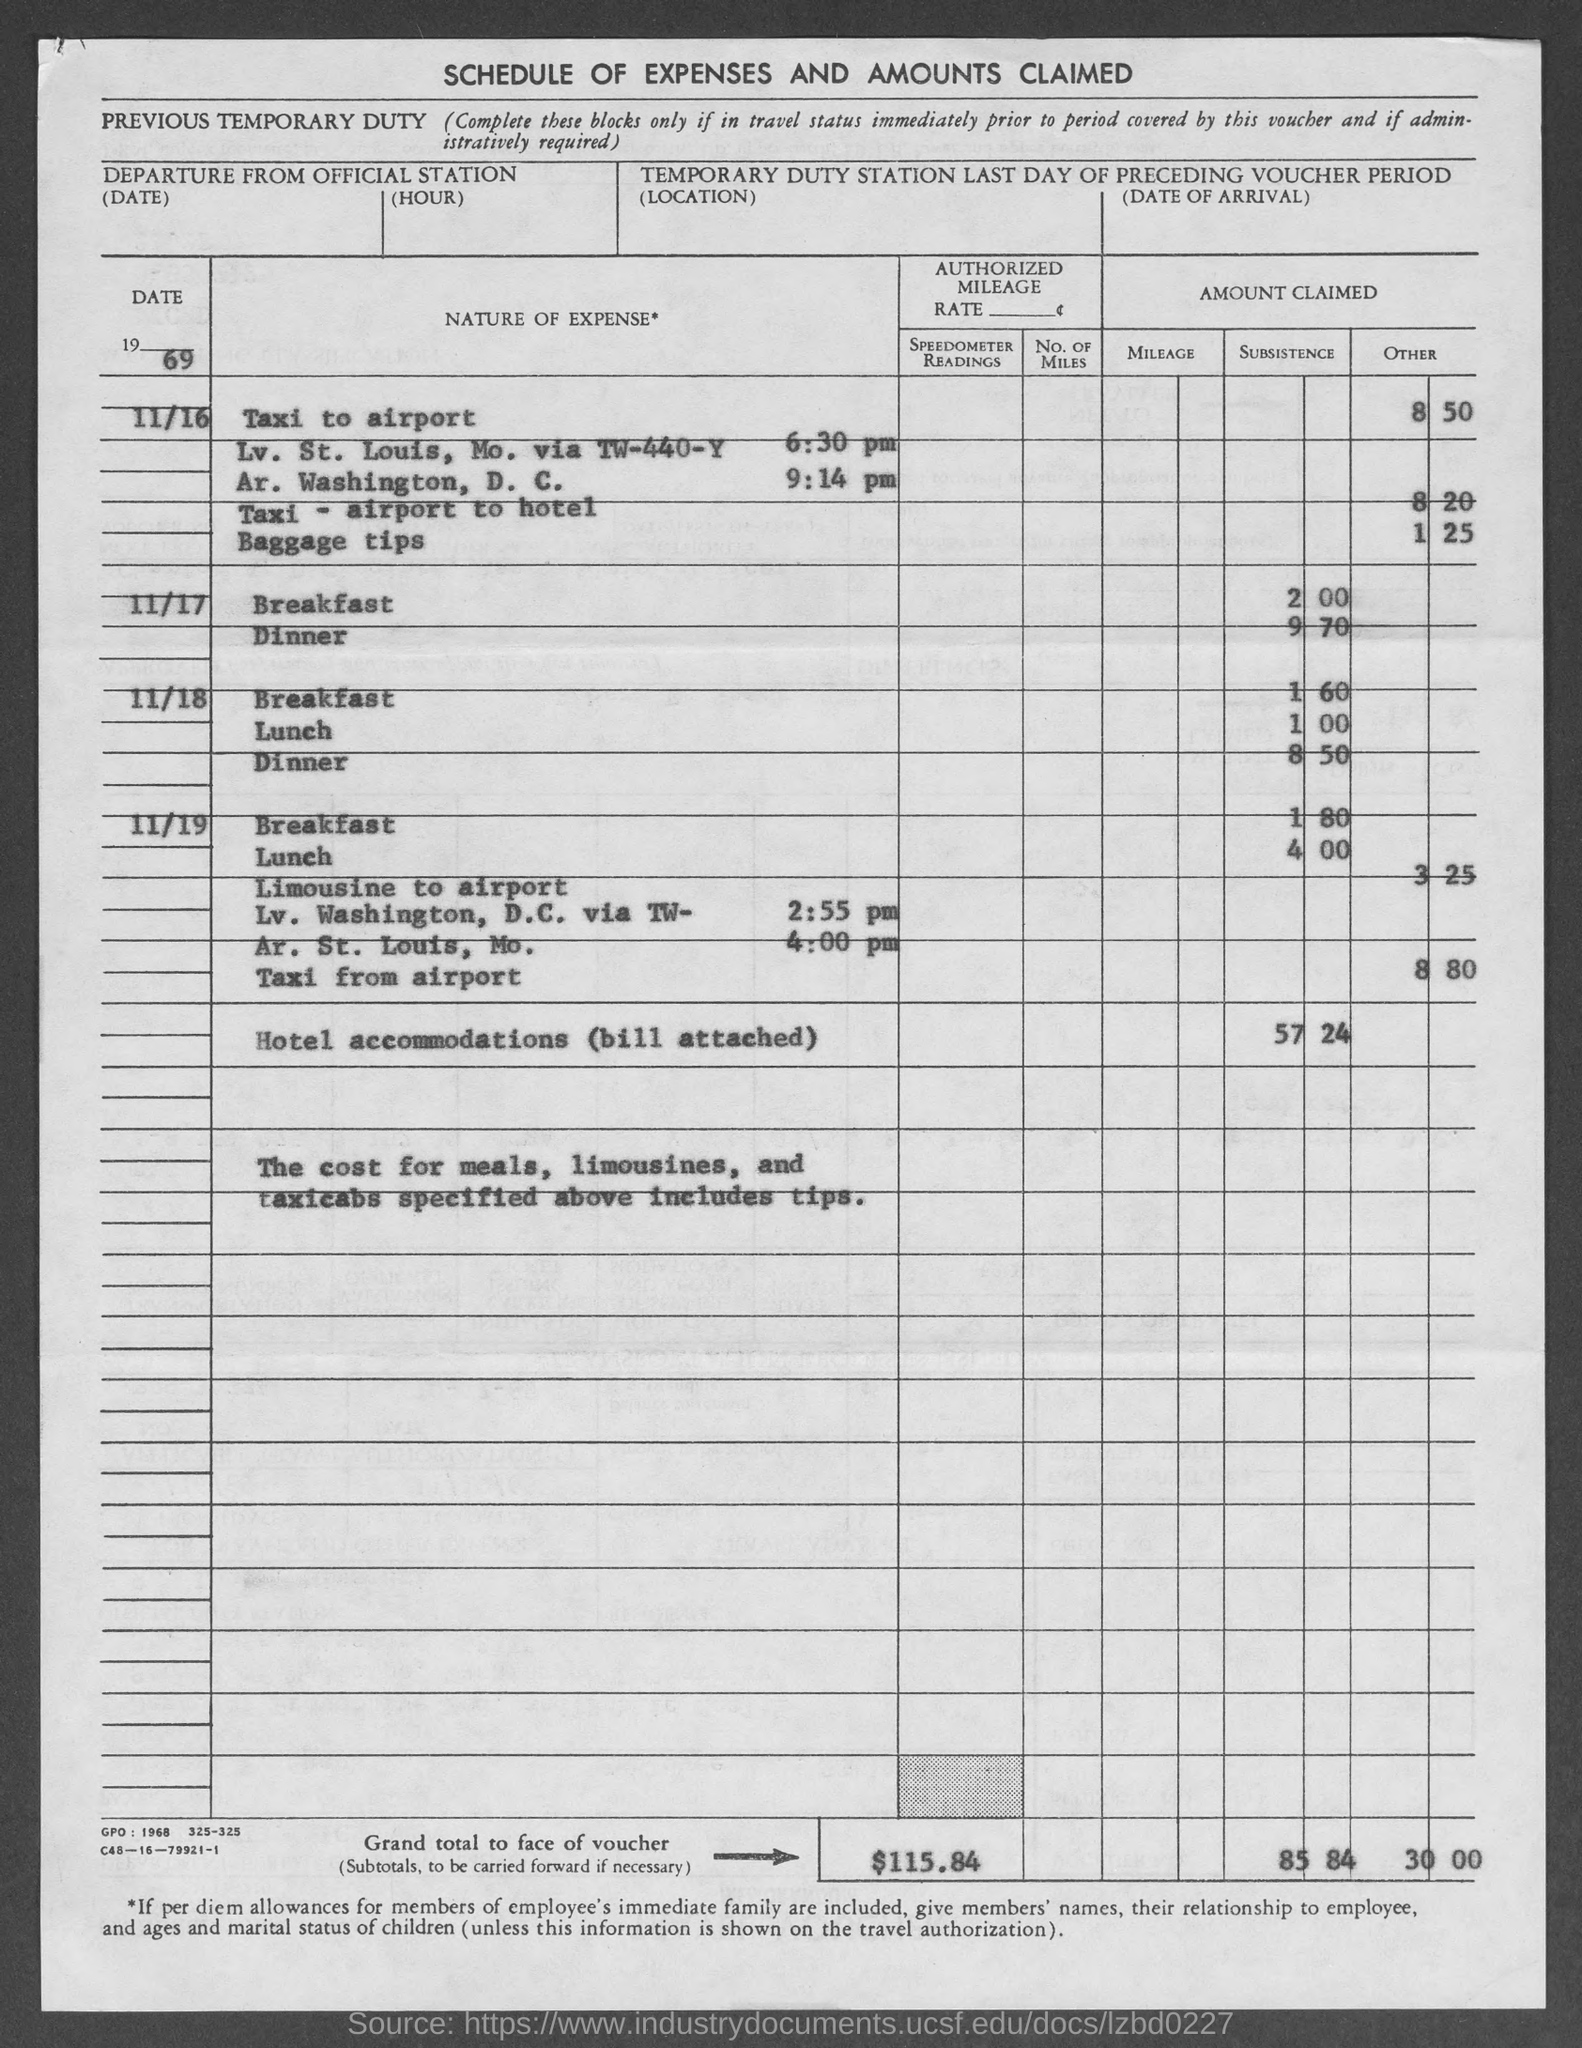Indicate a few pertinent items in this graphic. The total amount to be paid as per the voucher is $115.84. 